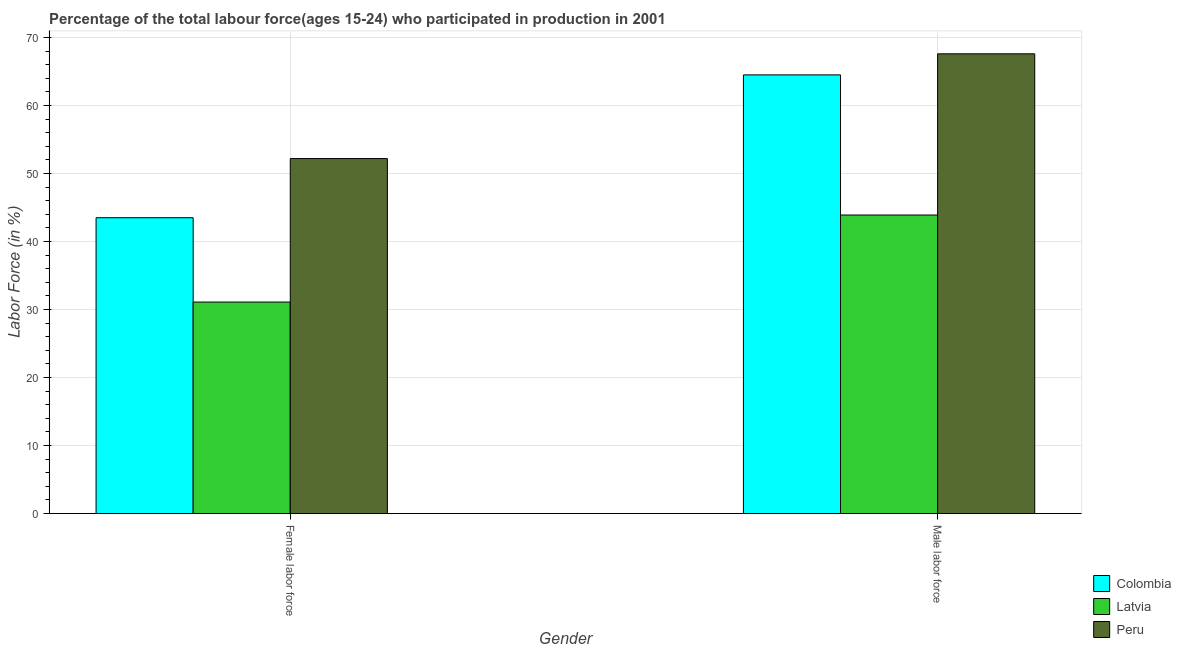How many different coloured bars are there?
Provide a short and direct response. 3. Are the number of bars on each tick of the X-axis equal?
Make the answer very short. Yes. What is the label of the 1st group of bars from the left?
Provide a succinct answer. Female labor force. What is the percentage of female labor force in Latvia?
Make the answer very short. 31.1. Across all countries, what is the maximum percentage of female labor force?
Keep it short and to the point. 52.2. Across all countries, what is the minimum percentage of female labor force?
Your answer should be very brief. 31.1. In which country was the percentage of female labor force minimum?
Provide a short and direct response. Latvia. What is the total percentage of female labor force in the graph?
Make the answer very short. 126.8. What is the difference between the percentage of female labor force in Peru and that in Colombia?
Offer a very short reply. 8.7. What is the difference between the percentage of female labor force in Latvia and the percentage of male labour force in Peru?
Give a very brief answer. -36.5. What is the average percentage of female labor force per country?
Ensure brevity in your answer.  42.27. What is the difference between the percentage of male labour force and percentage of female labor force in Latvia?
Provide a short and direct response. 12.8. What is the ratio of the percentage of male labour force in Latvia to that in Colombia?
Keep it short and to the point. 0.68. Is the percentage of male labour force in Peru less than that in Colombia?
Your answer should be very brief. No. In how many countries, is the percentage of male labour force greater than the average percentage of male labour force taken over all countries?
Offer a very short reply. 2. What does the 2nd bar from the left in Female labor force represents?
Your answer should be compact. Latvia. Are all the bars in the graph horizontal?
Offer a very short reply. No. What is the difference between two consecutive major ticks on the Y-axis?
Keep it short and to the point. 10. Where does the legend appear in the graph?
Your answer should be compact. Bottom right. What is the title of the graph?
Ensure brevity in your answer.  Percentage of the total labour force(ages 15-24) who participated in production in 2001. Does "Cameroon" appear as one of the legend labels in the graph?
Give a very brief answer. No. What is the Labor Force (in %) in Colombia in Female labor force?
Offer a very short reply. 43.5. What is the Labor Force (in %) of Latvia in Female labor force?
Provide a short and direct response. 31.1. What is the Labor Force (in %) of Peru in Female labor force?
Provide a short and direct response. 52.2. What is the Labor Force (in %) in Colombia in Male labor force?
Make the answer very short. 64.5. What is the Labor Force (in %) in Latvia in Male labor force?
Your response must be concise. 43.9. What is the Labor Force (in %) in Peru in Male labor force?
Make the answer very short. 67.6. Across all Gender, what is the maximum Labor Force (in %) in Colombia?
Provide a short and direct response. 64.5. Across all Gender, what is the maximum Labor Force (in %) of Latvia?
Provide a short and direct response. 43.9. Across all Gender, what is the maximum Labor Force (in %) of Peru?
Your answer should be very brief. 67.6. Across all Gender, what is the minimum Labor Force (in %) of Colombia?
Give a very brief answer. 43.5. Across all Gender, what is the minimum Labor Force (in %) in Latvia?
Ensure brevity in your answer.  31.1. Across all Gender, what is the minimum Labor Force (in %) of Peru?
Ensure brevity in your answer.  52.2. What is the total Labor Force (in %) in Colombia in the graph?
Offer a terse response. 108. What is the total Labor Force (in %) in Latvia in the graph?
Make the answer very short. 75. What is the total Labor Force (in %) of Peru in the graph?
Offer a very short reply. 119.8. What is the difference between the Labor Force (in %) in Colombia in Female labor force and that in Male labor force?
Offer a terse response. -21. What is the difference between the Labor Force (in %) of Peru in Female labor force and that in Male labor force?
Your response must be concise. -15.4. What is the difference between the Labor Force (in %) in Colombia in Female labor force and the Labor Force (in %) in Peru in Male labor force?
Keep it short and to the point. -24.1. What is the difference between the Labor Force (in %) in Latvia in Female labor force and the Labor Force (in %) in Peru in Male labor force?
Make the answer very short. -36.5. What is the average Labor Force (in %) in Colombia per Gender?
Provide a short and direct response. 54. What is the average Labor Force (in %) in Latvia per Gender?
Provide a short and direct response. 37.5. What is the average Labor Force (in %) of Peru per Gender?
Provide a succinct answer. 59.9. What is the difference between the Labor Force (in %) in Colombia and Labor Force (in %) in Peru in Female labor force?
Ensure brevity in your answer.  -8.7. What is the difference between the Labor Force (in %) of Latvia and Labor Force (in %) of Peru in Female labor force?
Offer a terse response. -21.1. What is the difference between the Labor Force (in %) of Colombia and Labor Force (in %) of Latvia in Male labor force?
Provide a short and direct response. 20.6. What is the difference between the Labor Force (in %) in Colombia and Labor Force (in %) in Peru in Male labor force?
Your answer should be compact. -3.1. What is the difference between the Labor Force (in %) in Latvia and Labor Force (in %) in Peru in Male labor force?
Ensure brevity in your answer.  -23.7. What is the ratio of the Labor Force (in %) of Colombia in Female labor force to that in Male labor force?
Offer a very short reply. 0.67. What is the ratio of the Labor Force (in %) of Latvia in Female labor force to that in Male labor force?
Make the answer very short. 0.71. What is the ratio of the Labor Force (in %) of Peru in Female labor force to that in Male labor force?
Give a very brief answer. 0.77. What is the difference between the highest and the second highest Labor Force (in %) of Colombia?
Ensure brevity in your answer.  21. What is the difference between the highest and the second highest Labor Force (in %) in Peru?
Offer a terse response. 15.4. What is the difference between the highest and the lowest Labor Force (in %) of Colombia?
Your answer should be compact. 21. 